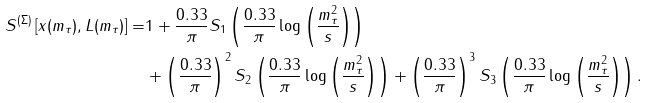Convert formula to latex. <formula><loc_0><loc_0><loc_500><loc_500>S ^ { ( \Sigma ) } \left [ x ( m _ { \tau } ) , L ( m _ { \tau } ) \right ] = & 1 + \frac { 0 . 3 3 } { \pi } S _ { 1 } \left ( \frac { 0 . 3 3 } { \pi } \log \left ( \frac { m _ { \tau } ^ { 2 } } { s } \right ) \right ) \\ & + \left ( \frac { 0 . 3 3 } { \pi } \right ) ^ { 2 } S _ { 2 } \left ( \frac { 0 . 3 3 } { \pi } \log \left ( \frac { m _ { \tau } ^ { 2 } } { s } \right ) \right ) + \left ( \frac { 0 . 3 3 } { \pi } \right ) ^ { 3 } S _ { 3 } \left ( \frac { 0 . 3 3 } { \pi } \log \left ( \frac { m _ { \tau } ^ { 2 } } { s } \right ) \right ) .</formula> 